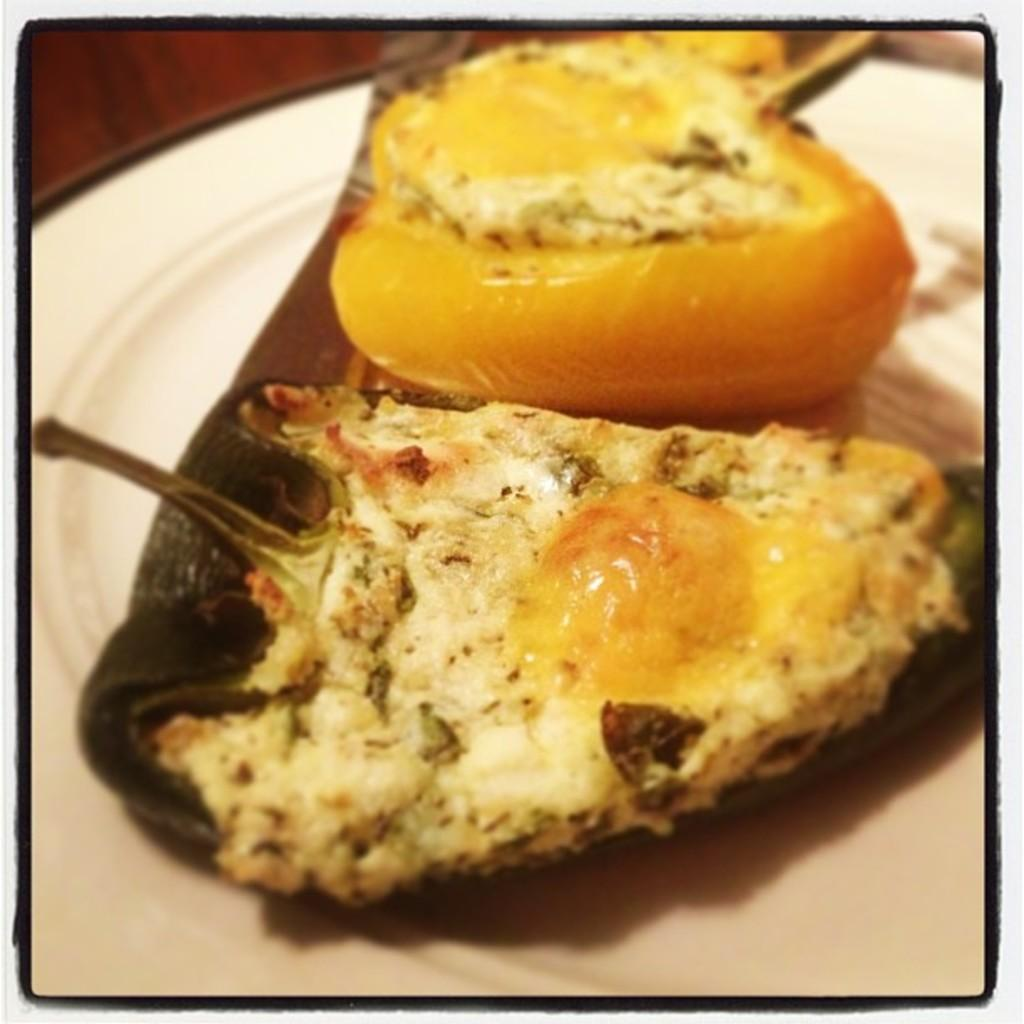What is present on the plate in the image? There is food in the white plate. Can you describe the color of the plate? The plate is white. What type of machine is being used to play volleyball in the image? There is no machine or volleyball present in the image; it only features a white plate with food on it. 